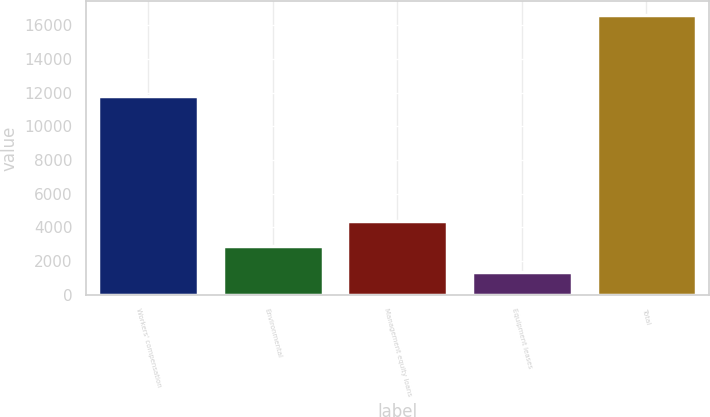Convert chart to OTSL. <chart><loc_0><loc_0><loc_500><loc_500><bar_chart><fcel>Workers' compensation<fcel>Environmental<fcel>Management equity loans<fcel>Equipment leases<fcel>Total<nl><fcel>11775<fcel>2856.1<fcel>4383.2<fcel>1329<fcel>16600<nl></chart> 